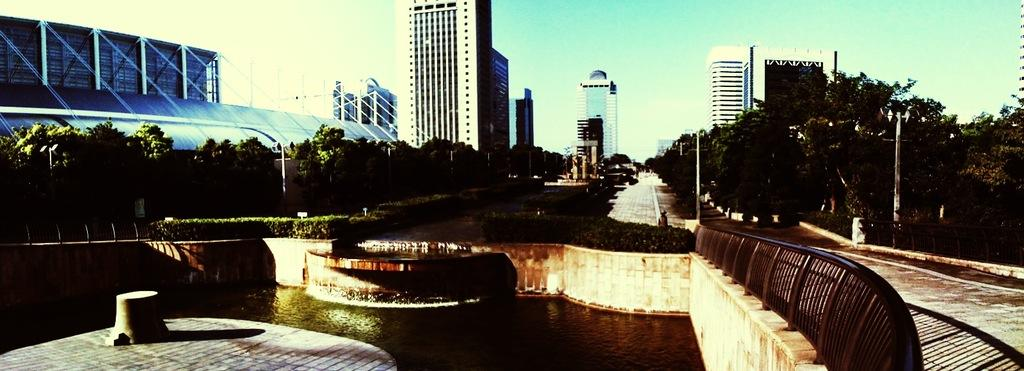What is the primary element visible in the image? Water is the primary element visible in the image. What other natural elements can be seen in the image? Plants, trees, and the sky are visible in the image. What man-made structures are present in the image? There are walls, railings, poles, a road, buildings, and a mobile in the image. How does the water in the image control the movement of the spacecraft? There is no spacecraft present in the image, and the water does not control any movement. 